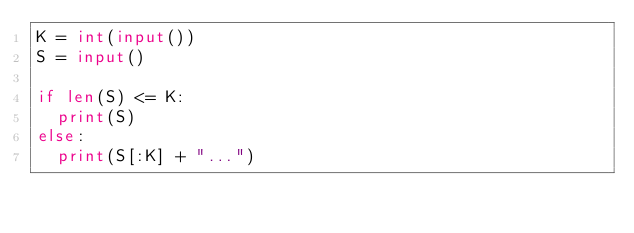Convert code to text. <code><loc_0><loc_0><loc_500><loc_500><_Python_>K = int(input())
S = input()

if len(S) <= K:
  print(S)
else:
  print(S[:K] + "...")</code> 